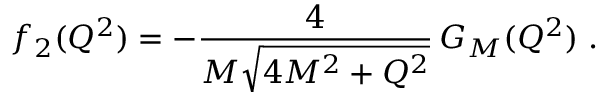Convert formula to latex. <formula><loc_0><loc_0><loc_500><loc_500>f _ { 2 } ( Q ^ { 2 } ) = - \frac { 4 } { M \sqrt { 4 M ^ { 2 } + Q ^ { 2 } } } \, G _ { M } ( Q ^ { 2 } ) \, .</formula> 